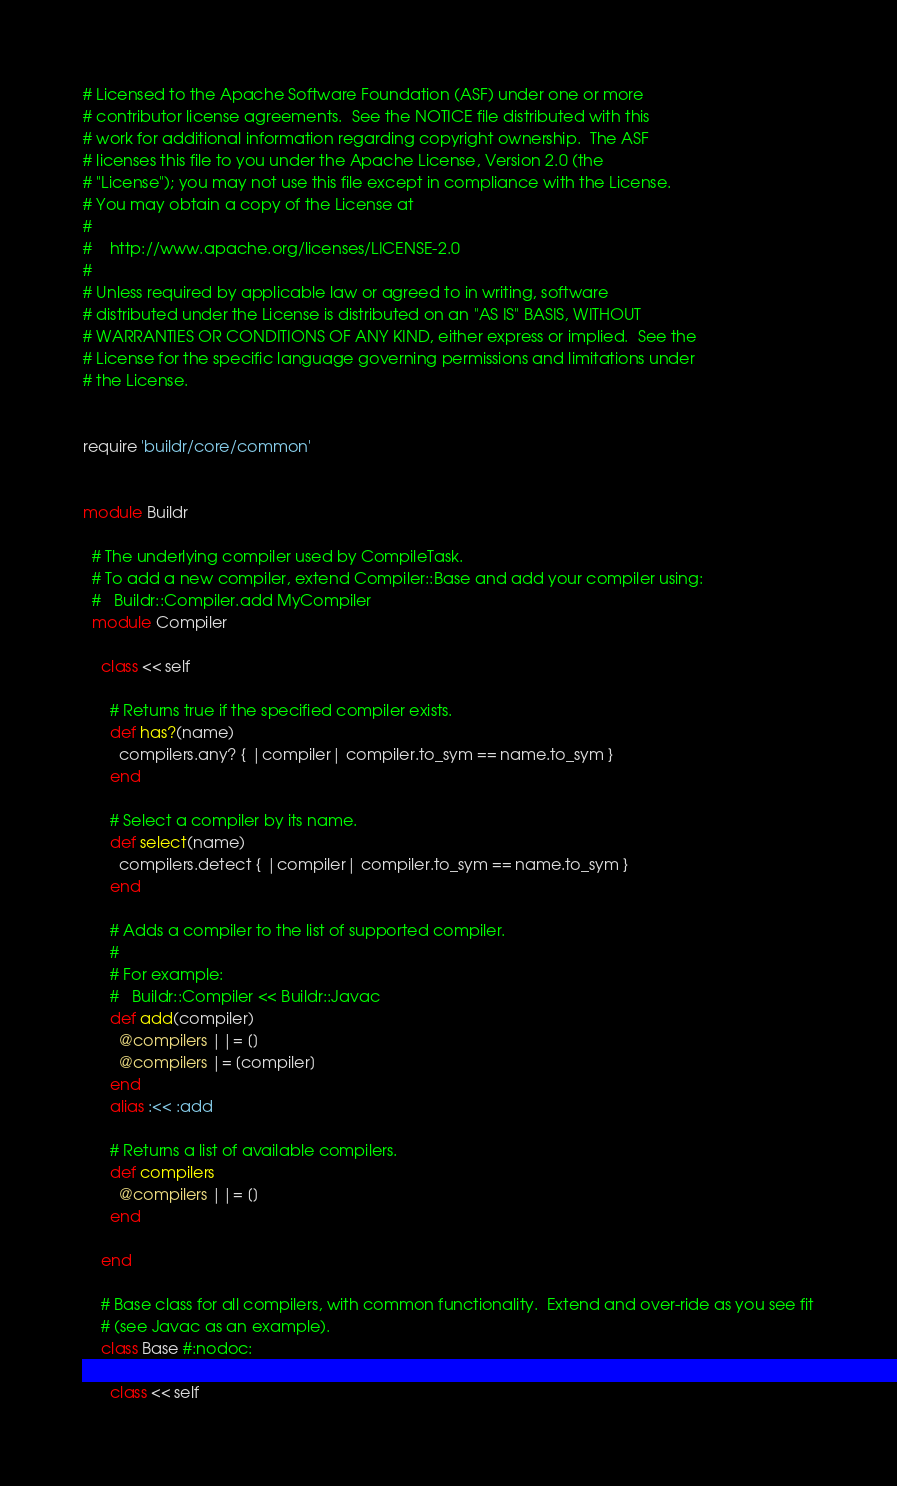Convert code to text. <code><loc_0><loc_0><loc_500><loc_500><_Ruby_># Licensed to the Apache Software Foundation (ASF) under one or more
# contributor license agreements.  See the NOTICE file distributed with this
# work for additional information regarding copyright ownership.  The ASF
# licenses this file to you under the Apache License, Version 2.0 (the
# "License"); you may not use this file except in compliance with the License.
# You may obtain a copy of the License at
#
#    http://www.apache.org/licenses/LICENSE-2.0
#
# Unless required by applicable law or agreed to in writing, software
# distributed under the License is distributed on an "AS IS" BASIS, WITHOUT
# WARRANTIES OR CONDITIONS OF ANY KIND, either express or implied.  See the
# License for the specific language governing permissions and limitations under
# the License.


require 'buildr/core/common'


module Buildr

  # The underlying compiler used by CompileTask.
  # To add a new compiler, extend Compiler::Base and add your compiler using:
  #   Buildr::Compiler.add MyCompiler
  module Compiler

    class << self

      # Returns true if the specified compiler exists.
      def has?(name)
        compilers.any? { |compiler| compiler.to_sym == name.to_sym }
      end

      # Select a compiler by its name.
      def select(name)
        compilers.detect { |compiler| compiler.to_sym == name.to_sym }
      end

      # Adds a compiler to the list of supported compiler.
      #   
      # For example:
      #   Buildr::Compiler << Buildr::Javac
      def add(compiler)
        @compilers ||= []
        @compilers |= [compiler]
      end
      alias :<< :add

      # Returns a list of available compilers.
      def compilers
        @compilers ||= []
      end

    end

    # Base class for all compilers, with common functionality.  Extend and over-ride as you see fit
    # (see Javac as an example).
    class Base #:nodoc:

      class << self
</code> 